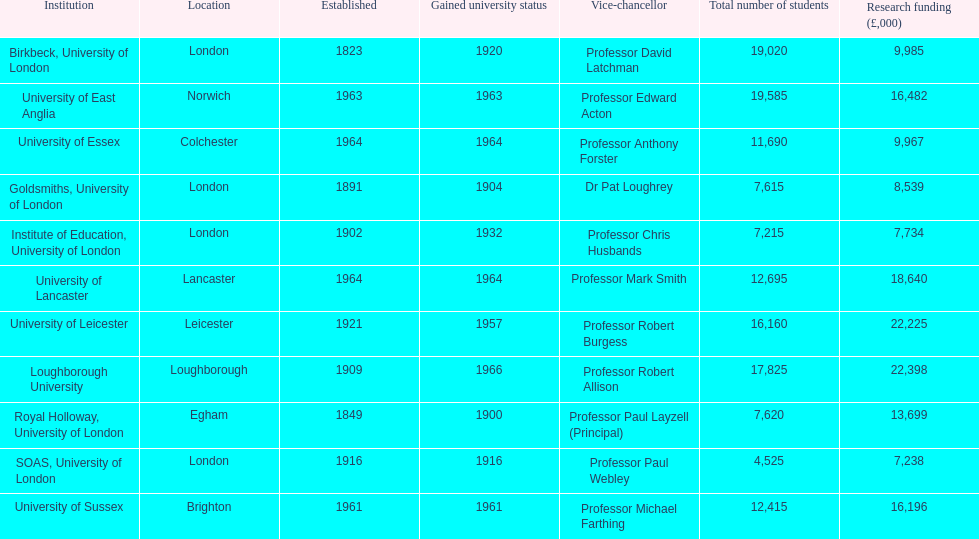What is the latest institution to acquire university status? Loughborough University. 